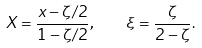Convert formula to latex. <formula><loc_0><loc_0><loc_500><loc_500>X = \frac { x - \zeta / 2 } { 1 - \zeta / 2 } , \quad \xi = \frac { \zeta } { 2 - \zeta } .</formula> 